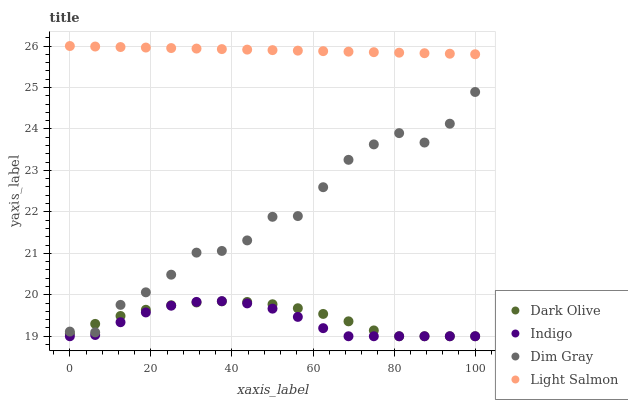Does Indigo have the minimum area under the curve?
Answer yes or no. Yes. Does Light Salmon have the maximum area under the curve?
Answer yes or no. Yes. Does Dark Olive have the minimum area under the curve?
Answer yes or no. No. Does Dark Olive have the maximum area under the curve?
Answer yes or no. No. Is Light Salmon the smoothest?
Answer yes or no. Yes. Is Dim Gray the roughest?
Answer yes or no. Yes. Is Dark Olive the smoothest?
Answer yes or no. No. Is Dark Olive the roughest?
Answer yes or no. No. Does Dark Olive have the lowest value?
Answer yes or no. Yes. Does Light Salmon have the lowest value?
Answer yes or no. No. Does Light Salmon have the highest value?
Answer yes or no. Yes. Does Indigo have the highest value?
Answer yes or no. No. Is Dark Olive less than Light Salmon?
Answer yes or no. Yes. Is Light Salmon greater than Indigo?
Answer yes or no. Yes. Does Indigo intersect Dark Olive?
Answer yes or no. Yes. Is Indigo less than Dark Olive?
Answer yes or no. No. Is Indigo greater than Dark Olive?
Answer yes or no. No. Does Dark Olive intersect Light Salmon?
Answer yes or no. No. 